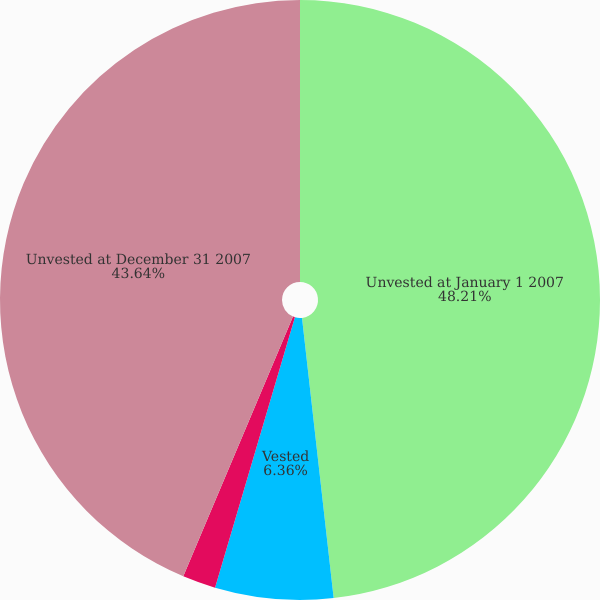<chart> <loc_0><loc_0><loc_500><loc_500><pie_chart><fcel>Unvested at January 1 2007<fcel>Vested<fcel>Forfeited<fcel>Unvested at December 31 2007<nl><fcel>48.21%<fcel>6.36%<fcel>1.79%<fcel>43.64%<nl></chart> 